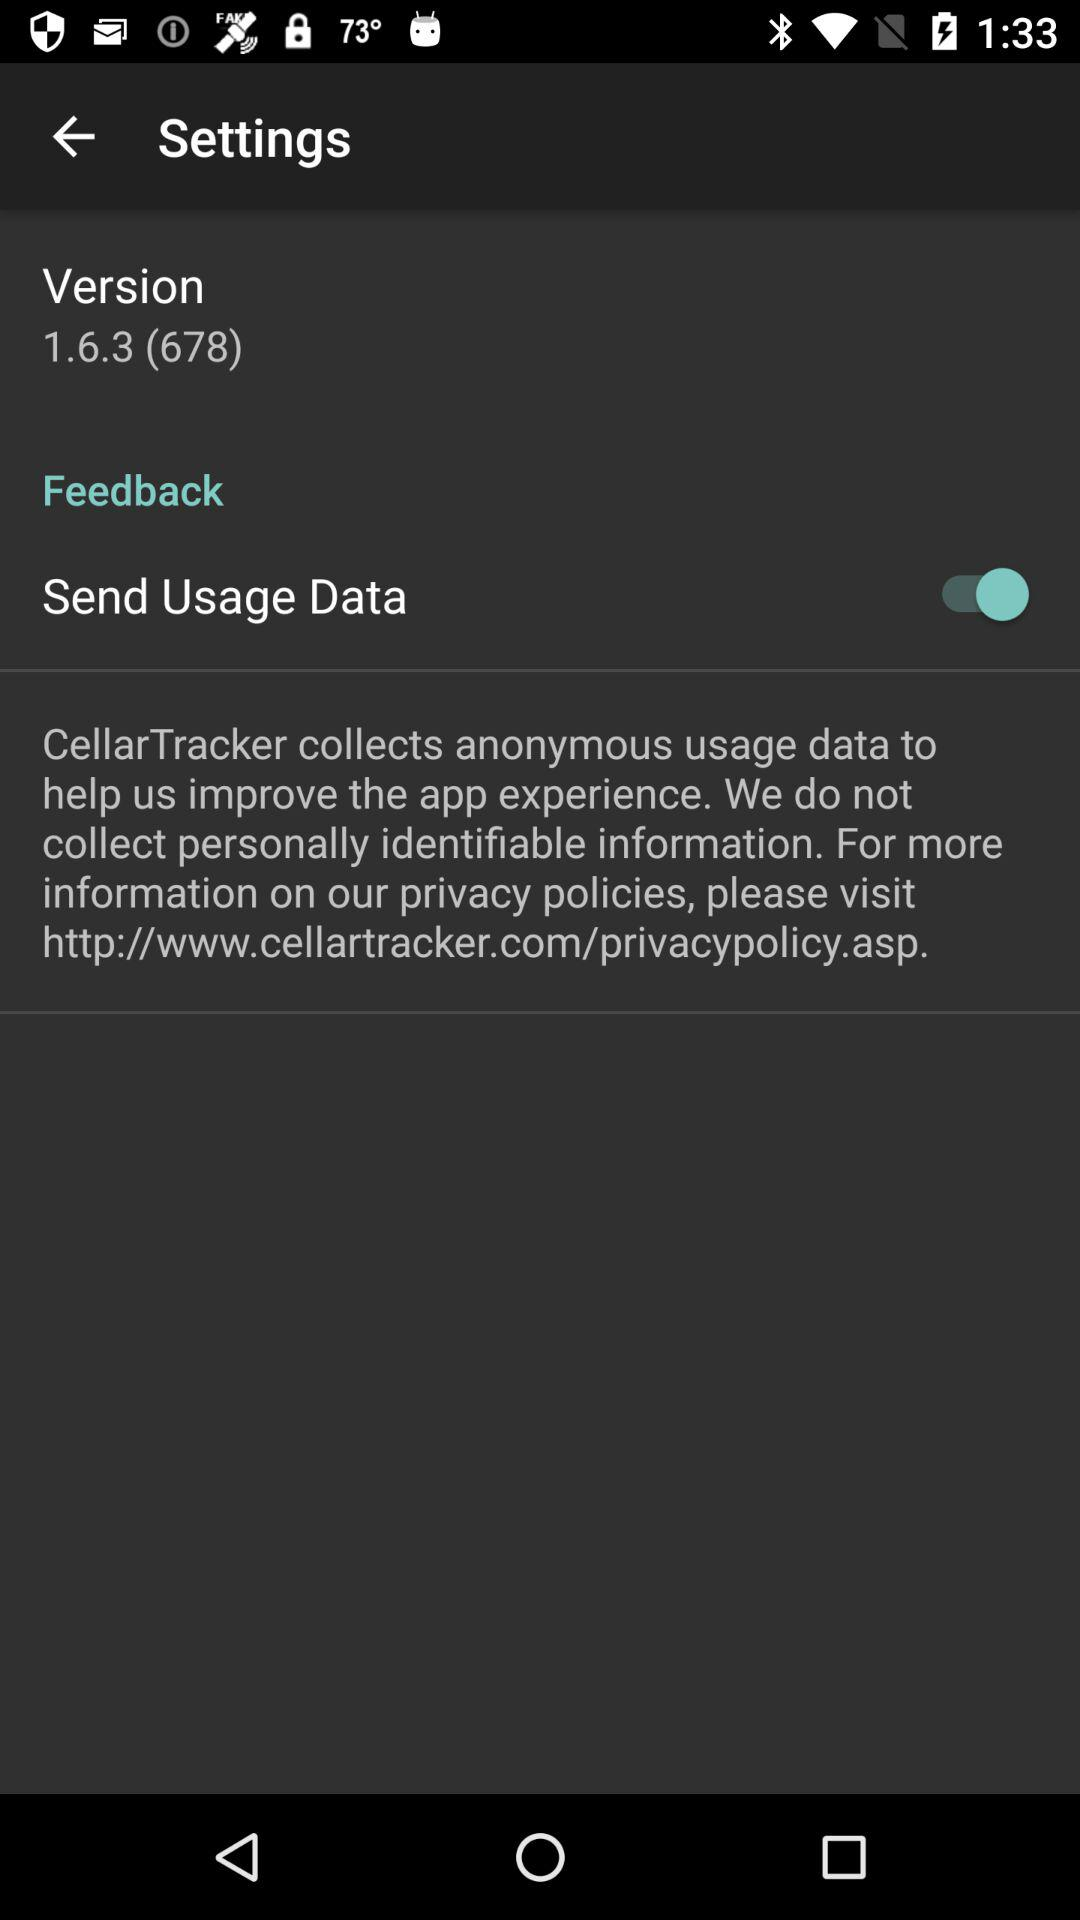What’s the status of the send usage data mode? The status is on. 